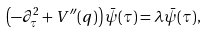<formula> <loc_0><loc_0><loc_500><loc_500>\left ( - \partial _ { \tau } ^ { 2 } + V ^ { \prime \prime } ( q ) \right ) \bar { \psi } ( \tau ) = \lambda \bar { \psi } ( \tau ) ,</formula> 